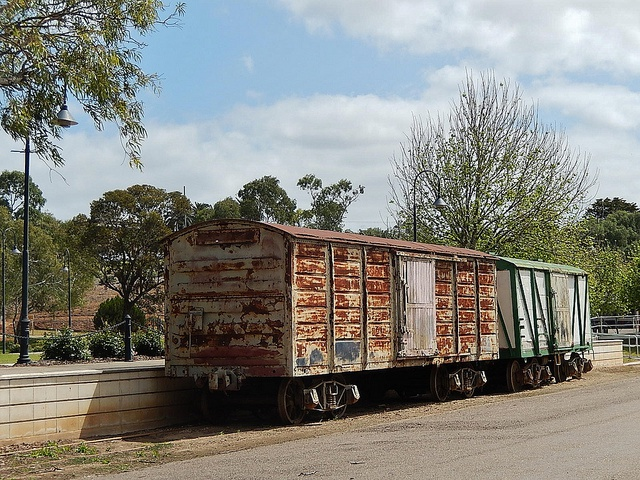Describe the objects in this image and their specific colors. I can see train in darkgray, black, maroon, and gray tones and truck in darkgray, black, maroon, and gray tones in this image. 